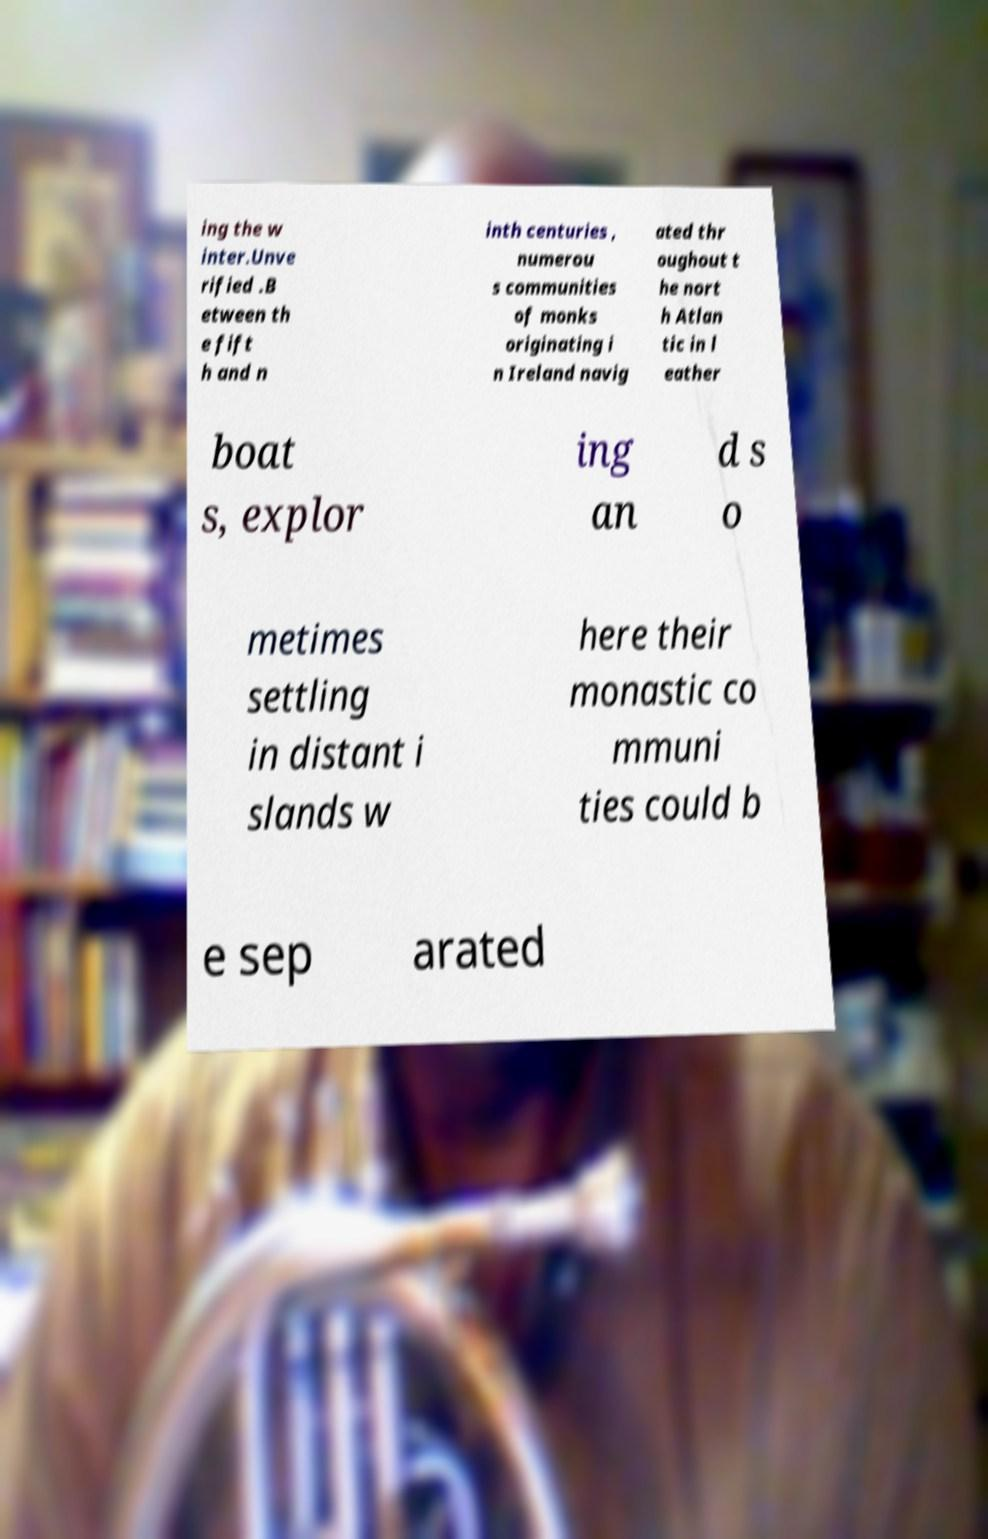I need the written content from this picture converted into text. Can you do that? ing the w inter.Unve rified .B etween th e fift h and n inth centuries , numerou s communities of monks originating i n Ireland navig ated thr oughout t he nort h Atlan tic in l eather boat s, explor ing an d s o metimes settling in distant i slands w here their monastic co mmuni ties could b e sep arated 